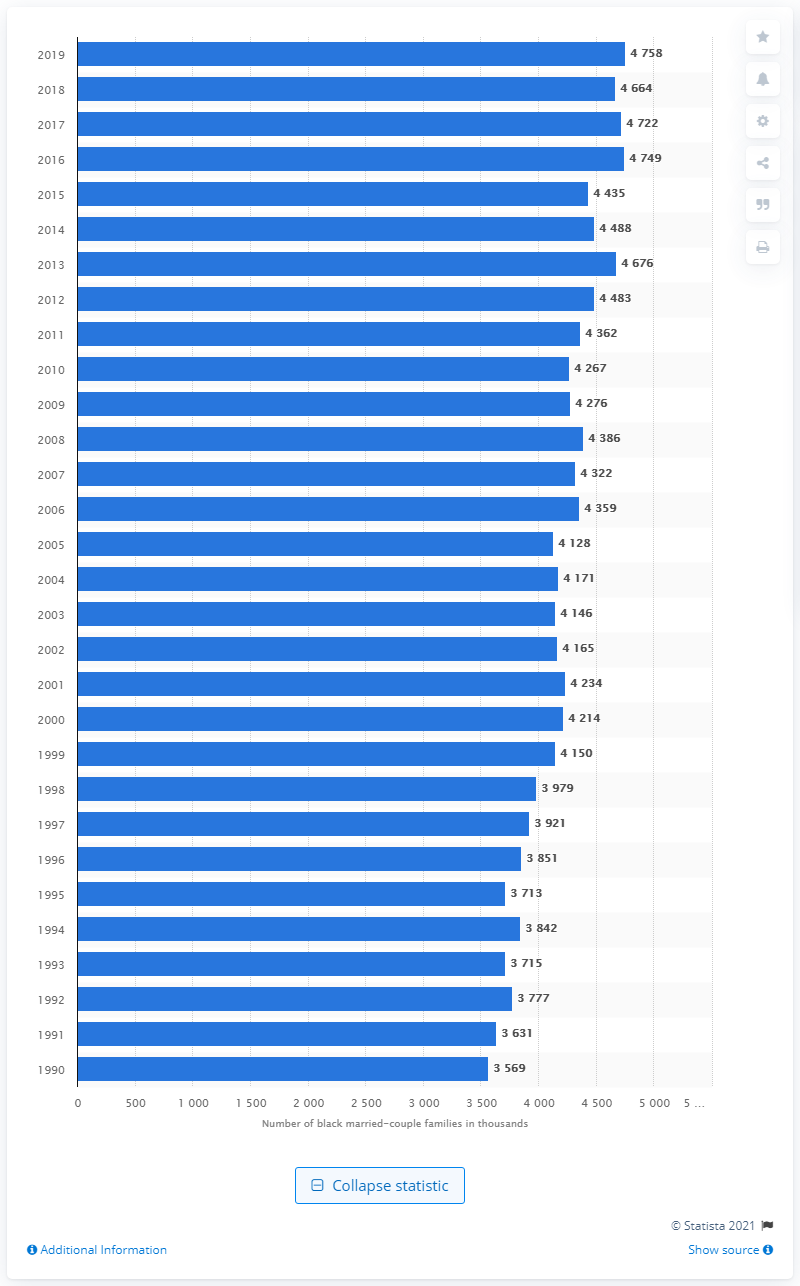Give some essential details in this illustration. In the year 1990, there were 3.57 million Black married-couple families in the United States. 